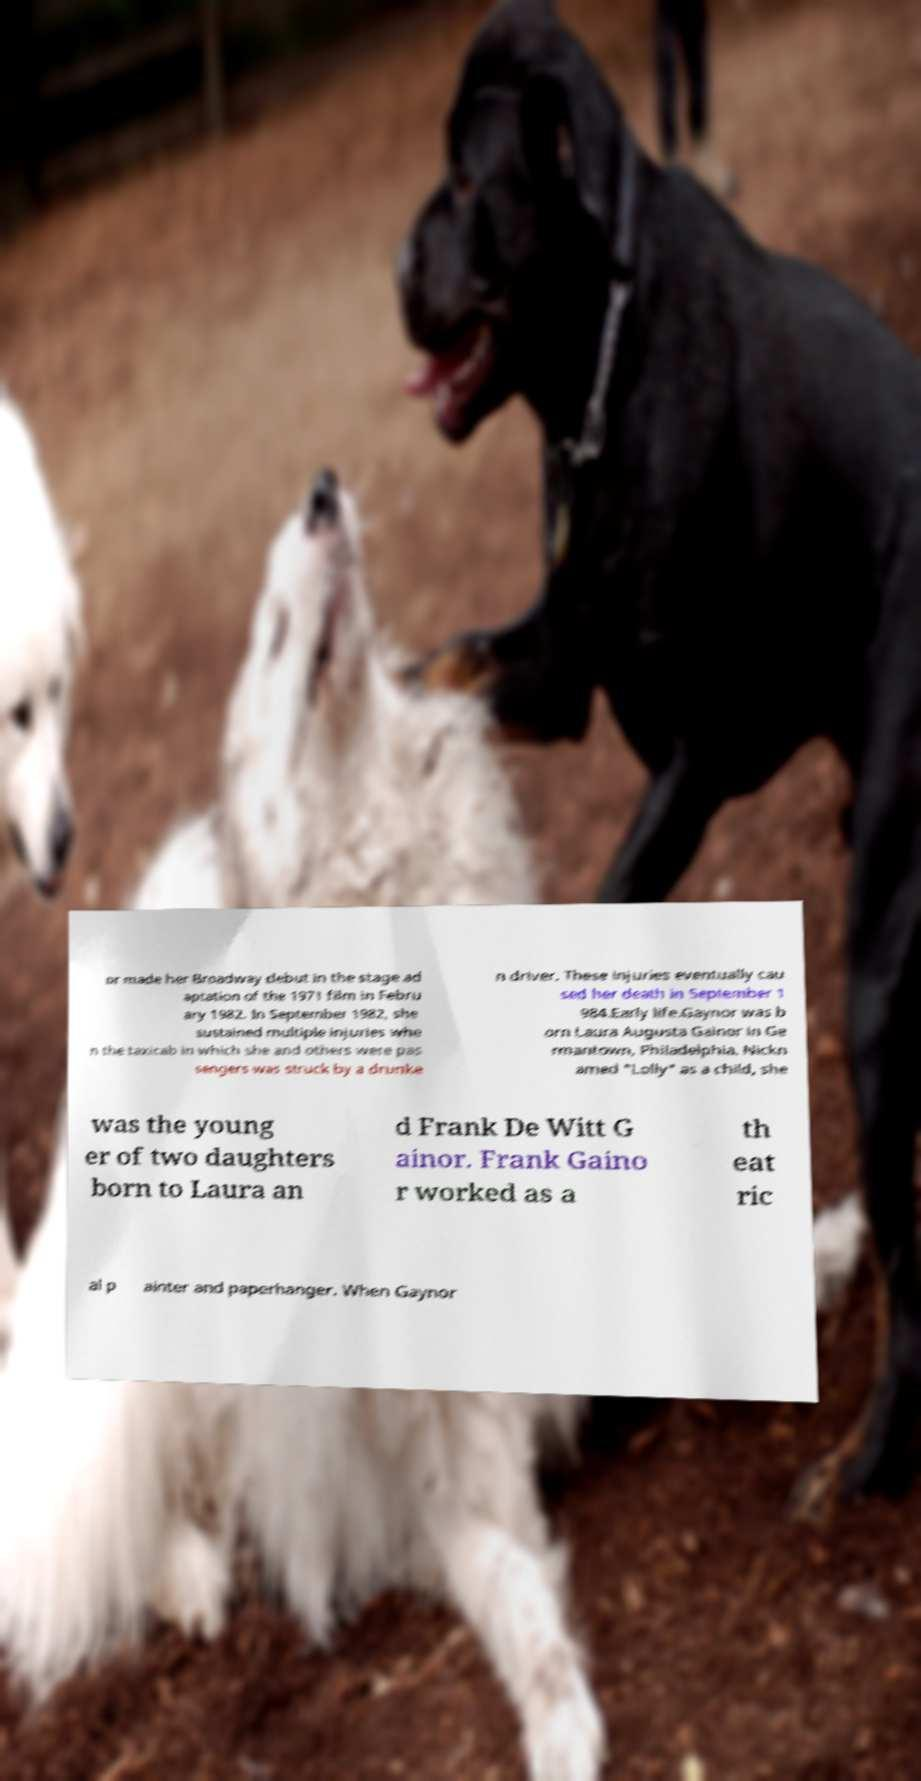Please identify and transcribe the text found in this image. or made her Broadway debut in the stage ad aptation of the 1971 film in Febru ary 1982. In September 1982, she sustained multiple injuries whe n the taxicab in which she and others were pas sengers was struck by a drunke n driver. These injuries eventually cau sed her death in September 1 984.Early life.Gaynor was b orn Laura Augusta Gainor in Ge rmantown, Philadelphia. Nickn amed "Lolly" as a child, she was the young er of two daughters born to Laura an d Frank De Witt G ainor. Frank Gaino r worked as a th eat ric al p ainter and paperhanger. When Gaynor 